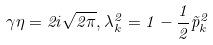<formula> <loc_0><loc_0><loc_500><loc_500>\gamma \eta = 2 i \sqrt { 2 \pi } , \lambda _ { k } ^ { 2 } = 1 - \frac { 1 } { 2 } \vec { p } _ { k } ^ { 2 }</formula> 